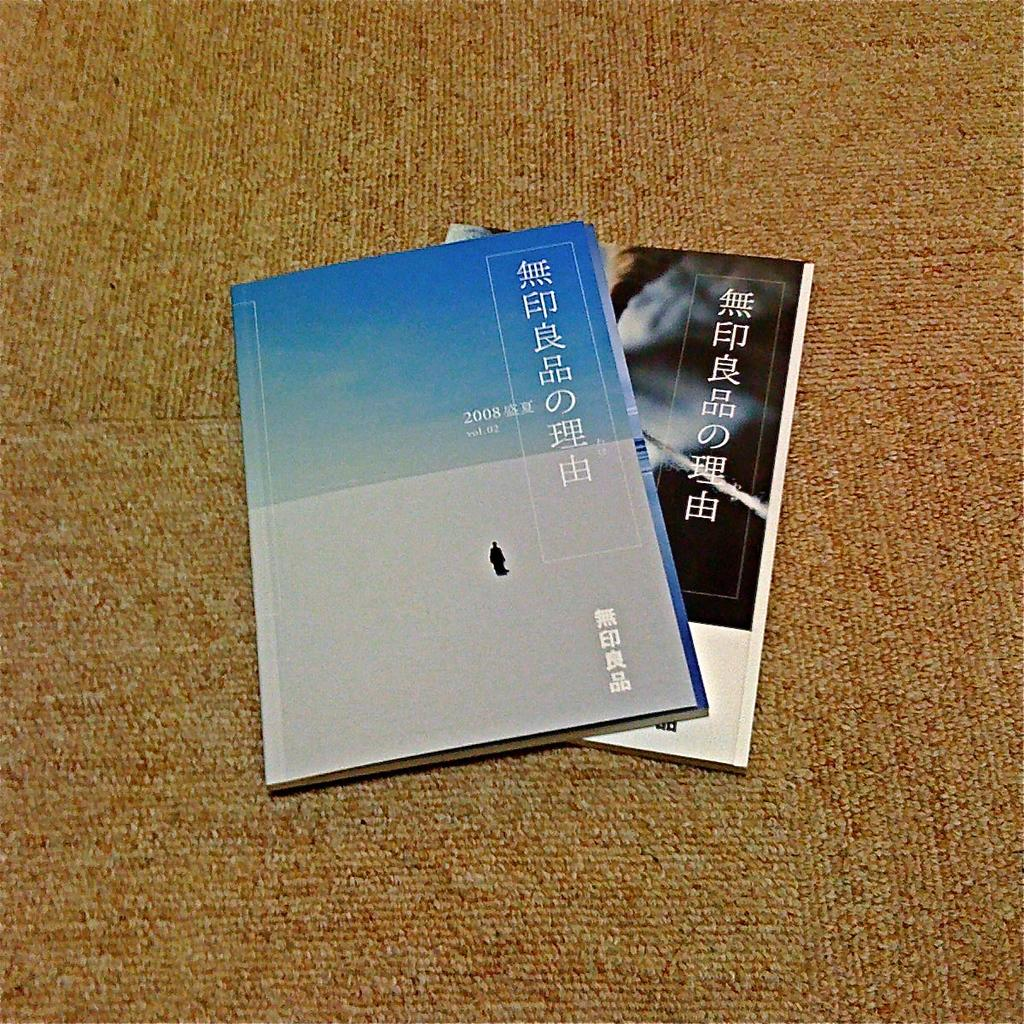Provide a one-sentence caption for the provided image. A booklet from 2008 is stacked on top of another booklet lying on the carpet. 